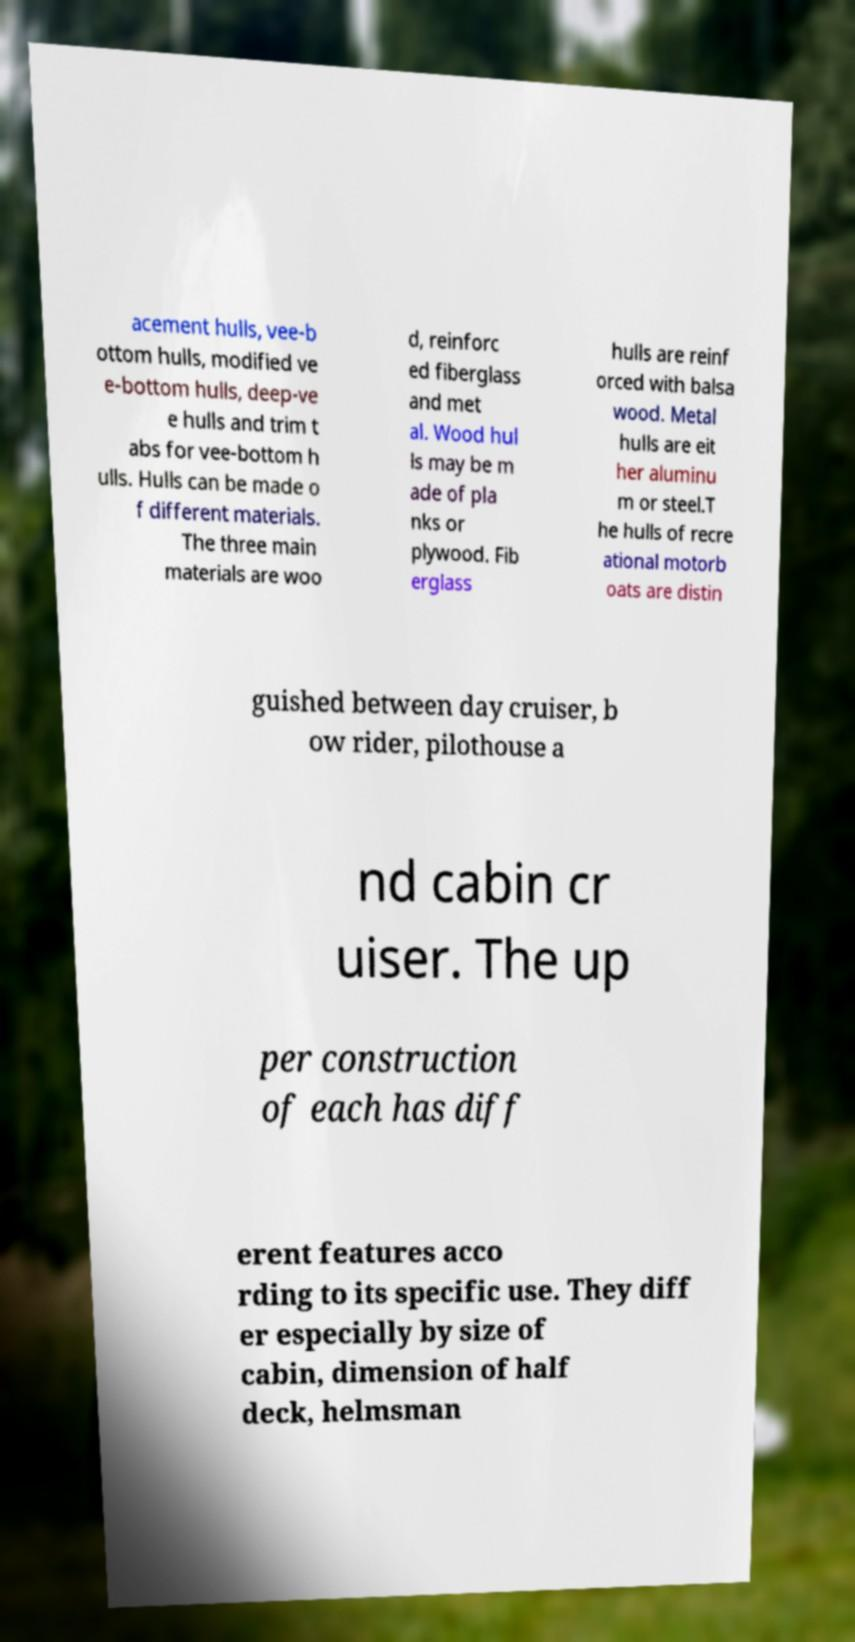For documentation purposes, I need the text within this image transcribed. Could you provide that? acement hulls, vee-b ottom hulls, modified ve e-bottom hulls, deep-ve e hulls and trim t abs for vee-bottom h ulls. Hulls can be made o f different materials. The three main materials are woo d, reinforc ed fiberglass and met al. Wood hul ls may be m ade of pla nks or plywood. Fib erglass hulls are reinf orced with balsa wood. Metal hulls are eit her aluminu m or steel.T he hulls of recre ational motorb oats are distin guished between day cruiser, b ow rider, pilothouse a nd cabin cr uiser. The up per construction of each has diff erent features acco rding to its specific use. They diff er especially by size of cabin, dimension of half deck, helmsman 